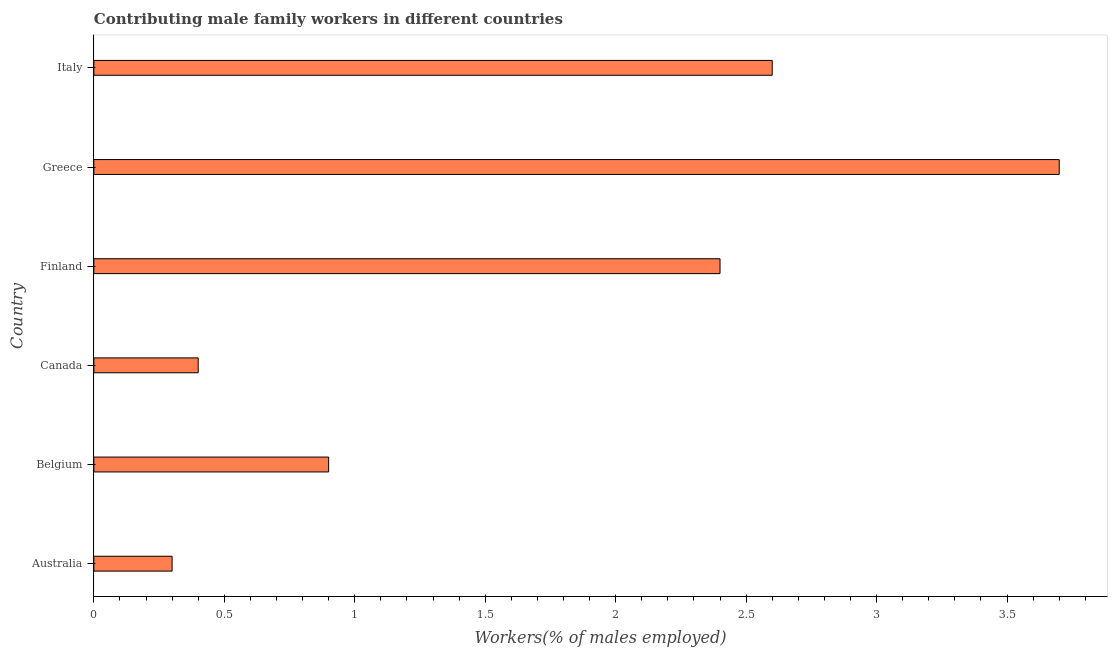Does the graph contain any zero values?
Provide a short and direct response. No. What is the title of the graph?
Provide a short and direct response. Contributing male family workers in different countries. What is the label or title of the X-axis?
Ensure brevity in your answer.  Workers(% of males employed). What is the contributing male family workers in Belgium?
Offer a terse response. 0.9. Across all countries, what is the maximum contributing male family workers?
Make the answer very short. 3.7. Across all countries, what is the minimum contributing male family workers?
Offer a terse response. 0.3. In which country was the contributing male family workers maximum?
Ensure brevity in your answer.  Greece. What is the sum of the contributing male family workers?
Provide a succinct answer. 10.3. What is the difference between the contributing male family workers in Australia and Finland?
Provide a succinct answer. -2.1. What is the average contributing male family workers per country?
Give a very brief answer. 1.72. What is the median contributing male family workers?
Keep it short and to the point. 1.65. What is the ratio of the contributing male family workers in Finland to that in Greece?
Your answer should be very brief. 0.65. Is the difference between the contributing male family workers in Finland and Italy greater than the difference between any two countries?
Provide a succinct answer. No. In how many countries, is the contributing male family workers greater than the average contributing male family workers taken over all countries?
Your answer should be compact. 3. Are all the bars in the graph horizontal?
Provide a short and direct response. Yes. What is the difference between two consecutive major ticks on the X-axis?
Your response must be concise. 0.5. What is the Workers(% of males employed) of Australia?
Ensure brevity in your answer.  0.3. What is the Workers(% of males employed) in Belgium?
Your response must be concise. 0.9. What is the Workers(% of males employed) of Canada?
Your answer should be very brief. 0.4. What is the Workers(% of males employed) in Finland?
Offer a terse response. 2.4. What is the Workers(% of males employed) in Greece?
Offer a terse response. 3.7. What is the Workers(% of males employed) of Italy?
Give a very brief answer. 2.6. What is the difference between the Workers(% of males employed) in Australia and Belgium?
Provide a short and direct response. -0.6. What is the difference between the Workers(% of males employed) in Australia and Italy?
Your answer should be very brief. -2.3. What is the difference between the Workers(% of males employed) in Belgium and Canada?
Your response must be concise. 0.5. What is the difference between the Workers(% of males employed) in Belgium and Finland?
Your response must be concise. -1.5. What is the difference between the Workers(% of males employed) in Belgium and Greece?
Make the answer very short. -2.8. What is the difference between the Workers(% of males employed) in Belgium and Italy?
Offer a terse response. -1.7. What is the difference between the Workers(% of males employed) in Canada and Finland?
Keep it short and to the point. -2. What is the difference between the Workers(% of males employed) in Canada and Greece?
Your answer should be very brief. -3.3. What is the difference between the Workers(% of males employed) in Finland and Italy?
Your answer should be very brief. -0.2. What is the difference between the Workers(% of males employed) in Greece and Italy?
Offer a very short reply. 1.1. What is the ratio of the Workers(% of males employed) in Australia to that in Belgium?
Provide a succinct answer. 0.33. What is the ratio of the Workers(% of males employed) in Australia to that in Greece?
Give a very brief answer. 0.08. What is the ratio of the Workers(% of males employed) in Australia to that in Italy?
Offer a terse response. 0.12. What is the ratio of the Workers(% of males employed) in Belgium to that in Canada?
Ensure brevity in your answer.  2.25. What is the ratio of the Workers(% of males employed) in Belgium to that in Greece?
Provide a succinct answer. 0.24. What is the ratio of the Workers(% of males employed) in Belgium to that in Italy?
Give a very brief answer. 0.35. What is the ratio of the Workers(% of males employed) in Canada to that in Finland?
Offer a very short reply. 0.17. What is the ratio of the Workers(% of males employed) in Canada to that in Greece?
Keep it short and to the point. 0.11. What is the ratio of the Workers(% of males employed) in Canada to that in Italy?
Offer a terse response. 0.15. What is the ratio of the Workers(% of males employed) in Finland to that in Greece?
Keep it short and to the point. 0.65. What is the ratio of the Workers(% of males employed) in Finland to that in Italy?
Give a very brief answer. 0.92. What is the ratio of the Workers(% of males employed) in Greece to that in Italy?
Make the answer very short. 1.42. 